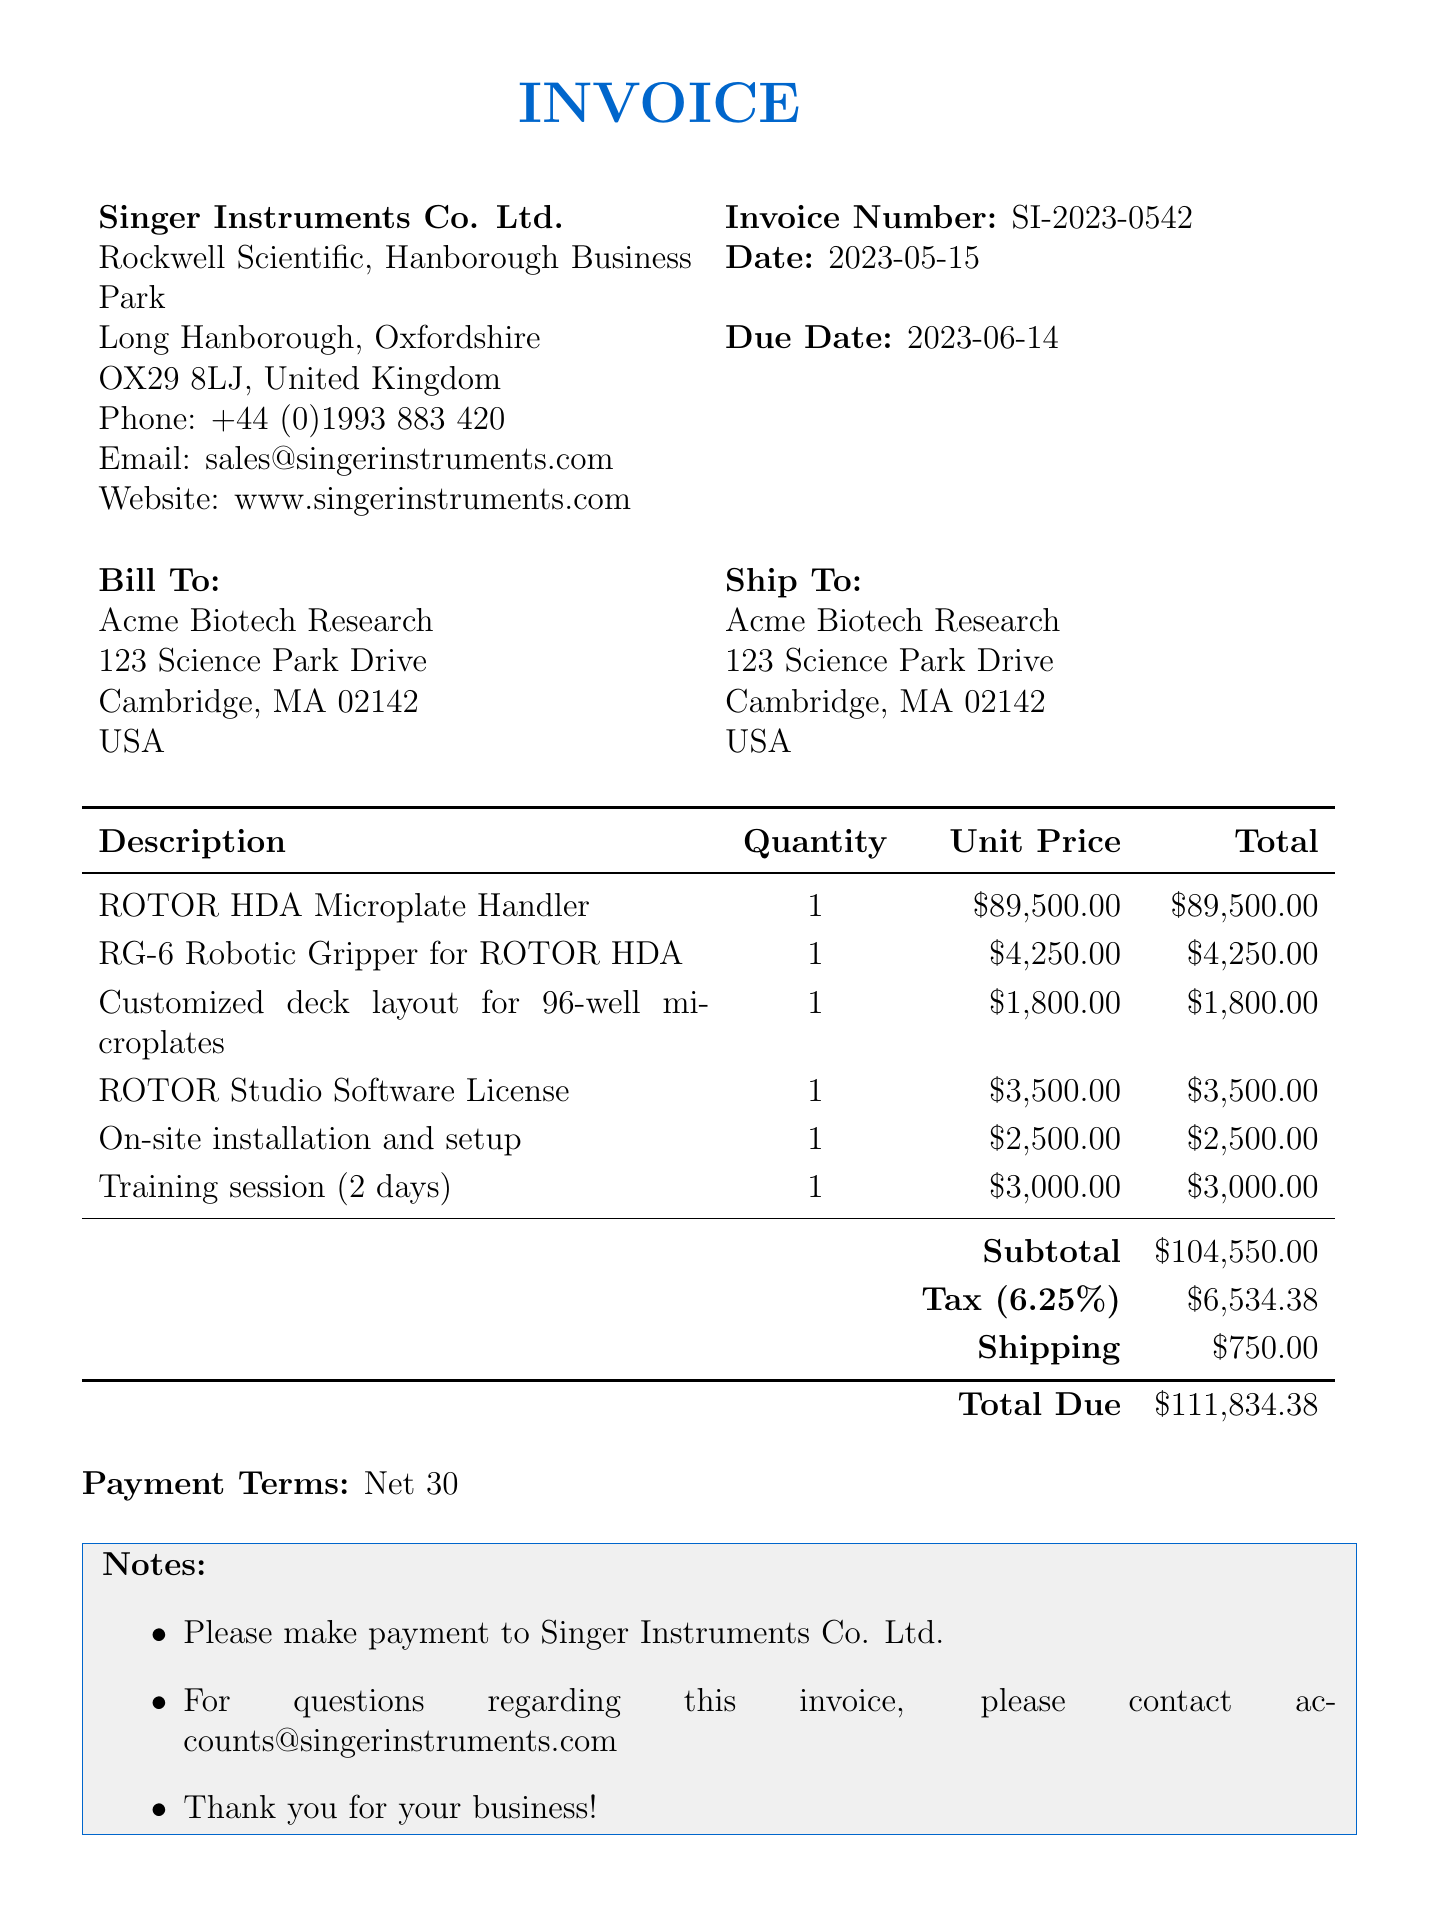What is the invoice number? The invoice number is specified at the top of the document as SI-2023-0542.
Answer: SI-2023-0542 What is the total amount due? The total due amount is calculated and stated at the bottom of the invoice as $111,834.38.
Answer: $111,834.38 Who is the seller of the products? The seller's information is provided at the beginning of the document, which indicates Singer Instruments Co. Ltd.
Answer: Singer Instruments Co. Ltd What is the tax rate applied? The tax rate is mentioned in the invoice as 6.25%.
Answer: 6.25% How many days is the training session scheduled for? The training session description indicates that it is for two days.
Answer: 2 days What is the payment term? The payment terms are mentioned at the bottom of the invoice indicating Net 30.
Answer: Net 30 What is included in the subtotal calculation? The subtotal includes the total amounts of items listed before tax, shipping, and other fees.
Answer: $104,550.00 What is the shipping cost? The shipping cost is listed as a separate item in the invoice as $750.00.
Answer: $750.00 What is the date of the invoice? The date of the invoice is specified towards the top as 2023-05-15.
Answer: 2023-05-15 